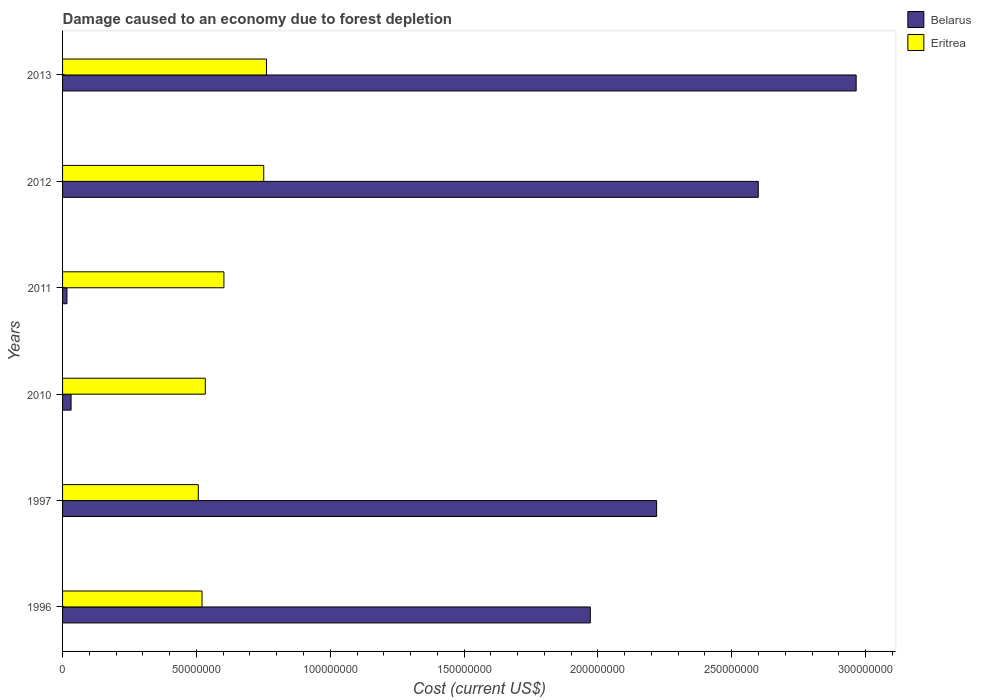How many groups of bars are there?
Your answer should be very brief. 6. Are the number of bars on each tick of the Y-axis equal?
Offer a very short reply. Yes. How many bars are there on the 4th tick from the top?
Give a very brief answer. 2. What is the label of the 4th group of bars from the top?
Ensure brevity in your answer.  2010. What is the cost of damage caused due to forest depletion in Belarus in 2013?
Make the answer very short. 2.96e+08. Across all years, what is the maximum cost of damage caused due to forest depletion in Belarus?
Your answer should be very brief. 2.96e+08. Across all years, what is the minimum cost of damage caused due to forest depletion in Eritrea?
Provide a succinct answer. 5.07e+07. In which year was the cost of damage caused due to forest depletion in Belarus minimum?
Offer a terse response. 2011. What is the total cost of damage caused due to forest depletion in Eritrea in the graph?
Ensure brevity in your answer.  3.68e+08. What is the difference between the cost of damage caused due to forest depletion in Eritrea in 1997 and that in 2013?
Ensure brevity in your answer.  -2.55e+07. What is the difference between the cost of damage caused due to forest depletion in Belarus in 2011 and the cost of damage caused due to forest depletion in Eritrea in 2012?
Your answer should be very brief. -7.35e+07. What is the average cost of damage caused due to forest depletion in Belarus per year?
Ensure brevity in your answer.  1.63e+08. In the year 2011, what is the difference between the cost of damage caused due to forest depletion in Belarus and cost of damage caused due to forest depletion in Eritrea?
Your answer should be compact. -5.86e+07. What is the ratio of the cost of damage caused due to forest depletion in Eritrea in 2010 to that in 2013?
Your answer should be compact. 0.7. Is the cost of damage caused due to forest depletion in Belarus in 1997 less than that in 2012?
Your response must be concise. Yes. Is the difference between the cost of damage caused due to forest depletion in Belarus in 1997 and 2012 greater than the difference between the cost of damage caused due to forest depletion in Eritrea in 1997 and 2012?
Give a very brief answer. No. What is the difference between the highest and the second highest cost of damage caused due to forest depletion in Eritrea?
Give a very brief answer. 1.03e+06. What is the difference between the highest and the lowest cost of damage caused due to forest depletion in Belarus?
Your answer should be very brief. 2.95e+08. In how many years, is the cost of damage caused due to forest depletion in Eritrea greater than the average cost of damage caused due to forest depletion in Eritrea taken over all years?
Keep it short and to the point. 2. What does the 1st bar from the top in 2011 represents?
Give a very brief answer. Eritrea. What does the 1st bar from the bottom in 1996 represents?
Your answer should be very brief. Belarus. How many years are there in the graph?
Provide a short and direct response. 6. What is the difference between two consecutive major ticks on the X-axis?
Your answer should be compact. 5.00e+07. Does the graph contain any zero values?
Provide a succinct answer. No. What is the title of the graph?
Keep it short and to the point. Damage caused to an economy due to forest depletion. Does "Middle income" appear as one of the legend labels in the graph?
Your answer should be very brief. No. What is the label or title of the X-axis?
Offer a terse response. Cost (current US$). What is the Cost (current US$) in Belarus in 1996?
Offer a terse response. 1.97e+08. What is the Cost (current US$) in Eritrea in 1996?
Make the answer very short. 5.21e+07. What is the Cost (current US$) in Belarus in 1997?
Give a very brief answer. 2.22e+08. What is the Cost (current US$) of Eritrea in 1997?
Your answer should be compact. 5.07e+07. What is the Cost (current US$) in Belarus in 2010?
Ensure brevity in your answer.  3.18e+06. What is the Cost (current US$) of Eritrea in 2010?
Ensure brevity in your answer.  5.33e+07. What is the Cost (current US$) in Belarus in 2011?
Give a very brief answer. 1.63e+06. What is the Cost (current US$) in Eritrea in 2011?
Provide a succinct answer. 6.03e+07. What is the Cost (current US$) in Belarus in 2012?
Provide a succinct answer. 2.60e+08. What is the Cost (current US$) of Eritrea in 2012?
Provide a short and direct response. 7.52e+07. What is the Cost (current US$) of Belarus in 2013?
Offer a terse response. 2.96e+08. What is the Cost (current US$) in Eritrea in 2013?
Your response must be concise. 7.62e+07. Across all years, what is the maximum Cost (current US$) of Belarus?
Give a very brief answer. 2.96e+08. Across all years, what is the maximum Cost (current US$) in Eritrea?
Your response must be concise. 7.62e+07. Across all years, what is the minimum Cost (current US$) of Belarus?
Your response must be concise. 1.63e+06. Across all years, what is the minimum Cost (current US$) of Eritrea?
Ensure brevity in your answer.  5.07e+07. What is the total Cost (current US$) in Belarus in the graph?
Offer a terse response. 9.80e+08. What is the total Cost (current US$) in Eritrea in the graph?
Offer a terse response. 3.68e+08. What is the difference between the Cost (current US$) in Belarus in 1996 and that in 1997?
Your answer should be very brief. -2.48e+07. What is the difference between the Cost (current US$) in Eritrea in 1996 and that in 1997?
Make the answer very short. 1.40e+06. What is the difference between the Cost (current US$) of Belarus in 1996 and that in 2010?
Provide a short and direct response. 1.94e+08. What is the difference between the Cost (current US$) of Eritrea in 1996 and that in 2010?
Your response must be concise. -1.22e+06. What is the difference between the Cost (current US$) of Belarus in 1996 and that in 2011?
Keep it short and to the point. 1.96e+08. What is the difference between the Cost (current US$) of Eritrea in 1996 and that in 2011?
Provide a short and direct response. -8.17e+06. What is the difference between the Cost (current US$) of Belarus in 1996 and that in 2012?
Your answer should be very brief. -6.27e+07. What is the difference between the Cost (current US$) in Eritrea in 1996 and that in 2012?
Offer a very short reply. -2.31e+07. What is the difference between the Cost (current US$) of Belarus in 1996 and that in 2013?
Your response must be concise. -9.93e+07. What is the difference between the Cost (current US$) of Eritrea in 1996 and that in 2013?
Provide a succinct answer. -2.41e+07. What is the difference between the Cost (current US$) in Belarus in 1997 and that in 2010?
Your answer should be compact. 2.19e+08. What is the difference between the Cost (current US$) in Eritrea in 1997 and that in 2010?
Give a very brief answer. -2.62e+06. What is the difference between the Cost (current US$) of Belarus in 1997 and that in 2011?
Keep it short and to the point. 2.20e+08. What is the difference between the Cost (current US$) in Eritrea in 1997 and that in 2011?
Offer a very short reply. -9.57e+06. What is the difference between the Cost (current US$) of Belarus in 1997 and that in 2012?
Offer a terse response. -3.80e+07. What is the difference between the Cost (current US$) in Eritrea in 1997 and that in 2012?
Offer a terse response. -2.45e+07. What is the difference between the Cost (current US$) of Belarus in 1997 and that in 2013?
Make the answer very short. -7.45e+07. What is the difference between the Cost (current US$) of Eritrea in 1997 and that in 2013?
Your answer should be compact. -2.55e+07. What is the difference between the Cost (current US$) in Belarus in 2010 and that in 2011?
Your response must be concise. 1.55e+06. What is the difference between the Cost (current US$) in Eritrea in 2010 and that in 2011?
Provide a succinct answer. -6.95e+06. What is the difference between the Cost (current US$) of Belarus in 2010 and that in 2012?
Your response must be concise. -2.57e+08. What is the difference between the Cost (current US$) in Eritrea in 2010 and that in 2012?
Your answer should be compact. -2.18e+07. What is the difference between the Cost (current US$) in Belarus in 2010 and that in 2013?
Your answer should be very brief. -2.93e+08. What is the difference between the Cost (current US$) in Eritrea in 2010 and that in 2013?
Your response must be concise. -2.29e+07. What is the difference between the Cost (current US$) of Belarus in 2011 and that in 2012?
Your answer should be compact. -2.58e+08. What is the difference between the Cost (current US$) of Eritrea in 2011 and that in 2012?
Your answer should be compact. -1.49e+07. What is the difference between the Cost (current US$) of Belarus in 2011 and that in 2013?
Make the answer very short. -2.95e+08. What is the difference between the Cost (current US$) in Eritrea in 2011 and that in 2013?
Give a very brief answer. -1.59e+07. What is the difference between the Cost (current US$) of Belarus in 2012 and that in 2013?
Ensure brevity in your answer.  -3.66e+07. What is the difference between the Cost (current US$) of Eritrea in 2012 and that in 2013?
Your response must be concise. -1.03e+06. What is the difference between the Cost (current US$) in Belarus in 1996 and the Cost (current US$) in Eritrea in 1997?
Ensure brevity in your answer.  1.46e+08. What is the difference between the Cost (current US$) in Belarus in 1996 and the Cost (current US$) in Eritrea in 2010?
Your response must be concise. 1.44e+08. What is the difference between the Cost (current US$) in Belarus in 1996 and the Cost (current US$) in Eritrea in 2011?
Provide a succinct answer. 1.37e+08. What is the difference between the Cost (current US$) of Belarus in 1996 and the Cost (current US$) of Eritrea in 2012?
Provide a succinct answer. 1.22e+08. What is the difference between the Cost (current US$) of Belarus in 1996 and the Cost (current US$) of Eritrea in 2013?
Your answer should be compact. 1.21e+08. What is the difference between the Cost (current US$) of Belarus in 1997 and the Cost (current US$) of Eritrea in 2010?
Offer a terse response. 1.69e+08. What is the difference between the Cost (current US$) of Belarus in 1997 and the Cost (current US$) of Eritrea in 2011?
Your response must be concise. 1.62e+08. What is the difference between the Cost (current US$) in Belarus in 1997 and the Cost (current US$) in Eritrea in 2012?
Make the answer very short. 1.47e+08. What is the difference between the Cost (current US$) of Belarus in 1997 and the Cost (current US$) of Eritrea in 2013?
Your response must be concise. 1.46e+08. What is the difference between the Cost (current US$) in Belarus in 2010 and the Cost (current US$) in Eritrea in 2011?
Ensure brevity in your answer.  -5.71e+07. What is the difference between the Cost (current US$) of Belarus in 2010 and the Cost (current US$) of Eritrea in 2012?
Your response must be concise. -7.20e+07. What is the difference between the Cost (current US$) in Belarus in 2010 and the Cost (current US$) in Eritrea in 2013?
Make the answer very short. -7.30e+07. What is the difference between the Cost (current US$) in Belarus in 2011 and the Cost (current US$) in Eritrea in 2012?
Provide a succinct answer. -7.35e+07. What is the difference between the Cost (current US$) in Belarus in 2011 and the Cost (current US$) in Eritrea in 2013?
Offer a terse response. -7.46e+07. What is the difference between the Cost (current US$) of Belarus in 2012 and the Cost (current US$) of Eritrea in 2013?
Offer a very short reply. 1.84e+08. What is the average Cost (current US$) of Belarus per year?
Provide a short and direct response. 1.63e+08. What is the average Cost (current US$) of Eritrea per year?
Give a very brief answer. 6.13e+07. In the year 1996, what is the difference between the Cost (current US$) in Belarus and Cost (current US$) in Eritrea?
Your answer should be compact. 1.45e+08. In the year 1997, what is the difference between the Cost (current US$) of Belarus and Cost (current US$) of Eritrea?
Your answer should be compact. 1.71e+08. In the year 2010, what is the difference between the Cost (current US$) of Belarus and Cost (current US$) of Eritrea?
Your answer should be very brief. -5.01e+07. In the year 2011, what is the difference between the Cost (current US$) of Belarus and Cost (current US$) of Eritrea?
Offer a very short reply. -5.86e+07. In the year 2012, what is the difference between the Cost (current US$) in Belarus and Cost (current US$) in Eritrea?
Your response must be concise. 1.85e+08. In the year 2013, what is the difference between the Cost (current US$) of Belarus and Cost (current US$) of Eritrea?
Your response must be concise. 2.20e+08. What is the ratio of the Cost (current US$) of Belarus in 1996 to that in 1997?
Offer a very short reply. 0.89. What is the ratio of the Cost (current US$) in Eritrea in 1996 to that in 1997?
Your response must be concise. 1.03. What is the ratio of the Cost (current US$) in Belarus in 1996 to that in 2010?
Ensure brevity in your answer.  61.96. What is the ratio of the Cost (current US$) in Eritrea in 1996 to that in 2010?
Your answer should be compact. 0.98. What is the ratio of the Cost (current US$) in Belarus in 1996 to that in 2011?
Offer a very short reply. 120.82. What is the ratio of the Cost (current US$) in Eritrea in 1996 to that in 2011?
Provide a short and direct response. 0.86. What is the ratio of the Cost (current US$) of Belarus in 1996 to that in 2012?
Keep it short and to the point. 0.76. What is the ratio of the Cost (current US$) of Eritrea in 1996 to that in 2012?
Make the answer very short. 0.69. What is the ratio of the Cost (current US$) in Belarus in 1996 to that in 2013?
Provide a succinct answer. 0.67. What is the ratio of the Cost (current US$) in Eritrea in 1996 to that in 2013?
Make the answer very short. 0.68. What is the ratio of the Cost (current US$) in Belarus in 1997 to that in 2010?
Make the answer very short. 69.75. What is the ratio of the Cost (current US$) of Eritrea in 1997 to that in 2010?
Ensure brevity in your answer.  0.95. What is the ratio of the Cost (current US$) in Belarus in 1997 to that in 2011?
Provide a short and direct response. 136. What is the ratio of the Cost (current US$) in Eritrea in 1997 to that in 2011?
Keep it short and to the point. 0.84. What is the ratio of the Cost (current US$) of Belarus in 1997 to that in 2012?
Offer a very short reply. 0.85. What is the ratio of the Cost (current US$) in Eritrea in 1997 to that in 2012?
Your response must be concise. 0.67. What is the ratio of the Cost (current US$) in Belarus in 1997 to that in 2013?
Offer a terse response. 0.75. What is the ratio of the Cost (current US$) in Eritrea in 1997 to that in 2013?
Your answer should be compact. 0.67. What is the ratio of the Cost (current US$) of Belarus in 2010 to that in 2011?
Provide a short and direct response. 1.95. What is the ratio of the Cost (current US$) of Eritrea in 2010 to that in 2011?
Your response must be concise. 0.88. What is the ratio of the Cost (current US$) of Belarus in 2010 to that in 2012?
Ensure brevity in your answer.  0.01. What is the ratio of the Cost (current US$) in Eritrea in 2010 to that in 2012?
Offer a terse response. 0.71. What is the ratio of the Cost (current US$) in Belarus in 2010 to that in 2013?
Offer a very short reply. 0.01. What is the ratio of the Cost (current US$) of Eritrea in 2010 to that in 2013?
Your response must be concise. 0.7. What is the ratio of the Cost (current US$) of Belarus in 2011 to that in 2012?
Offer a terse response. 0.01. What is the ratio of the Cost (current US$) in Eritrea in 2011 to that in 2012?
Your response must be concise. 0.8. What is the ratio of the Cost (current US$) in Belarus in 2011 to that in 2013?
Give a very brief answer. 0.01. What is the ratio of the Cost (current US$) in Eritrea in 2011 to that in 2013?
Provide a succinct answer. 0.79. What is the ratio of the Cost (current US$) in Belarus in 2012 to that in 2013?
Your answer should be compact. 0.88. What is the ratio of the Cost (current US$) of Eritrea in 2012 to that in 2013?
Give a very brief answer. 0.99. What is the difference between the highest and the second highest Cost (current US$) in Belarus?
Ensure brevity in your answer.  3.66e+07. What is the difference between the highest and the second highest Cost (current US$) of Eritrea?
Offer a very short reply. 1.03e+06. What is the difference between the highest and the lowest Cost (current US$) in Belarus?
Keep it short and to the point. 2.95e+08. What is the difference between the highest and the lowest Cost (current US$) of Eritrea?
Make the answer very short. 2.55e+07. 